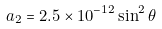Convert formula to latex. <formula><loc_0><loc_0><loc_500><loc_500>a _ { 2 } = 2 . 5 \times 1 0 ^ { - 1 2 } \sin ^ { 2 } \theta</formula> 